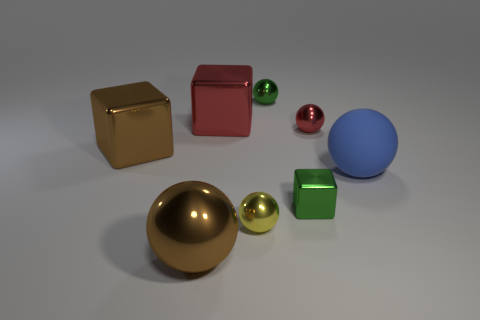Subtract 2 balls. How many balls are left? 3 Subtract all red balls. How many balls are left? 4 Subtract all tiny yellow balls. How many balls are left? 4 Subtract all purple balls. Subtract all red cylinders. How many balls are left? 5 Add 2 big red metal objects. How many objects exist? 10 Subtract all balls. How many objects are left? 3 Subtract 1 red blocks. How many objects are left? 7 Subtract all brown blocks. Subtract all tiny red objects. How many objects are left? 6 Add 5 large red metallic blocks. How many large red metallic blocks are left? 6 Add 3 tiny yellow objects. How many tiny yellow objects exist? 4 